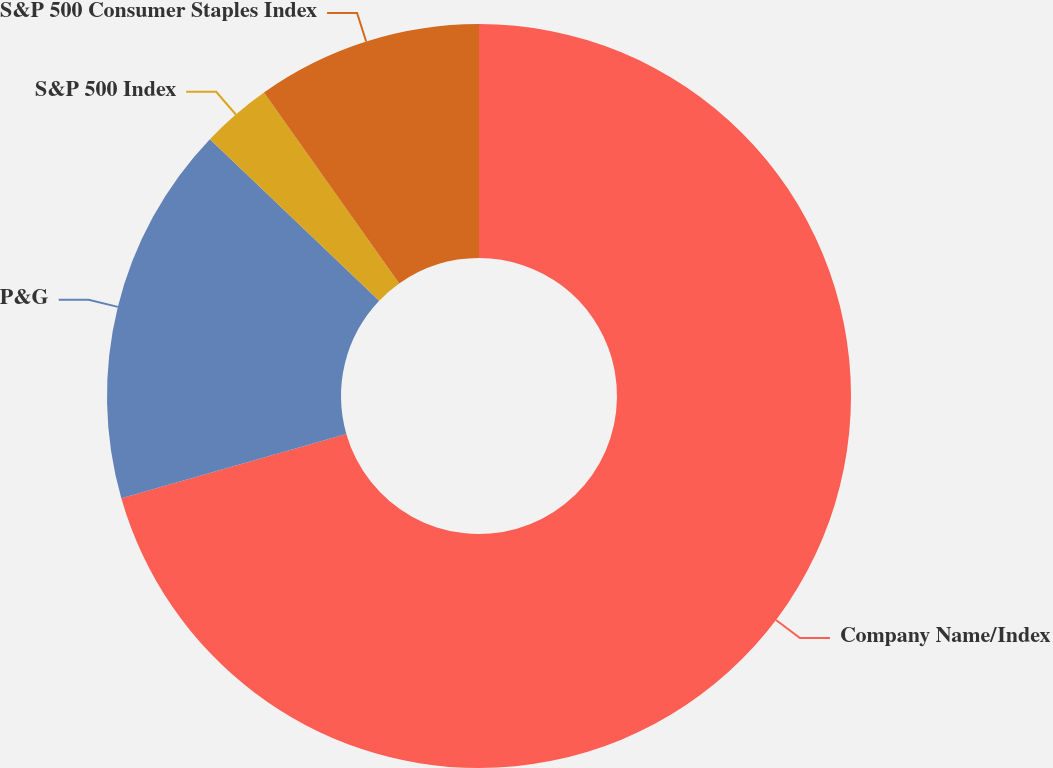Convert chart. <chart><loc_0><loc_0><loc_500><loc_500><pie_chart><fcel>Company Name/Index<fcel>P&G<fcel>S&P 500 Index<fcel>S&P 500 Consumer Staples Index<nl><fcel>70.57%<fcel>16.56%<fcel>3.06%<fcel>9.81%<nl></chart> 